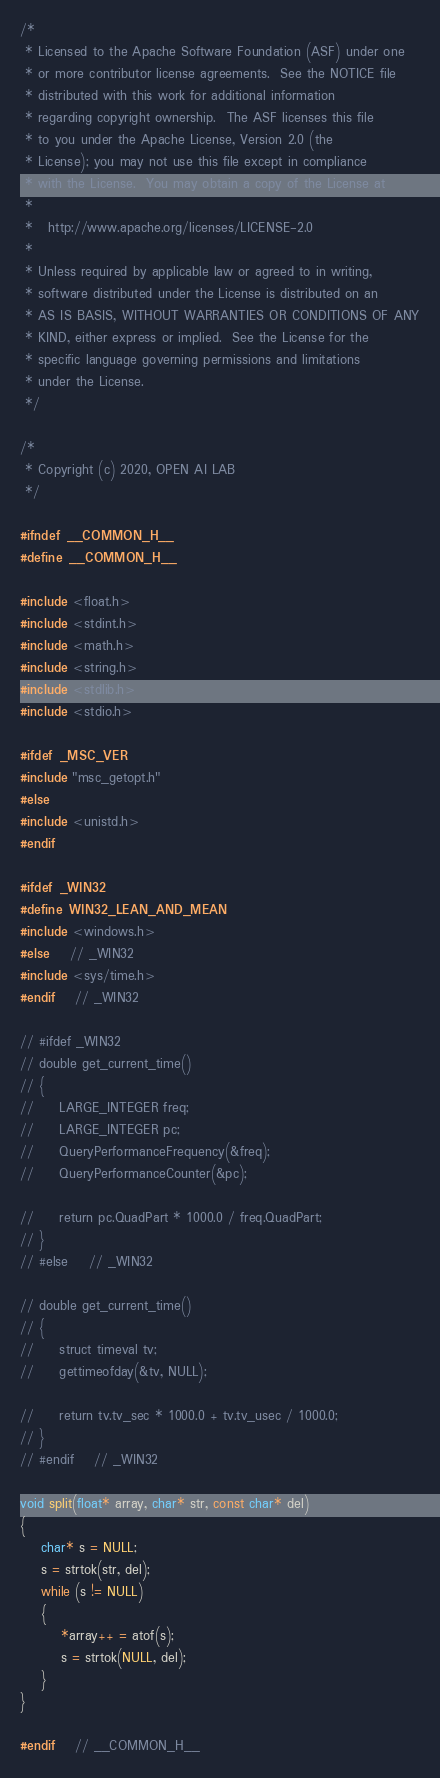Convert code to text. <code><loc_0><loc_0><loc_500><loc_500><_C_>/*
 * Licensed to the Apache Software Foundation (ASF) under one
 * or more contributor license agreements.  See the NOTICE file
 * distributed with this work for additional information
 * regarding copyright ownership.  The ASF licenses this file
 * to you under the Apache License, Version 2.0 (the
 * License); you may not use this file except in compliance
 * with the License.  You may obtain a copy of the License at
 *
 *   http://www.apache.org/licenses/LICENSE-2.0
 *
 * Unless required by applicable law or agreed to in writing,
 * software distributed under the License is distributed on an
 * AS IS BASIS, WITHOUT WARRANTIES OR CONDITIONS OF ANY
 * KIND, either express or implied.  See the License for the
 * specific language governing permissions and limitations
 * under the License.
 */

/*
 * Copyright (c) 2020, OPEN AI LAB
 */

#ifndef __COMMON_H__
#define __COMMON_H__

#include <float.h>
#include <stdint.h>
#include <math.h>
#include <string.h>
#include <stdlib.h>
#include <stdio.h>

#ifdef _MSC_VER
#include "msc_getopt.h"
#else
#include <unistd.h>
#endif

#ifdef _WIN32
#define WIN32_LEAN_AND_MEAN
#include <windows.h>
#else    // _WIN32
#include <sys/time.h>
#endif    // _WIN32

// #ifdef _WIN32
// double get_current_time()
// {
//     LARGE_INTEGER freq;
//     LARGE_INTEGER pc;
//     QueryPerformanceFrequency(&freq);
//     QueryPerformanceCounter(&pc);

//     return pc.QuadPart * 1000.0 / freq.QuadPart;
// }
// #else    // _WIN32

// double get_current_time()
// {
//     struct timeval tv;
//     gettimeofday(&tv, NULL);

//     return tv.tv_sec * 1000.0 + tv.tv_usec / 1000.0;
// }
// #endif    // _WIN32

void split(float* array, char* str, const char* del)
{
    char* s = NULL;
    s = strtok(str, del);
    while (s != NULL)
    {
        *array++ = atof(s);
        s = strtok(NULL, del);
    }
}

#endif    // __COMMON_H__
</code> 